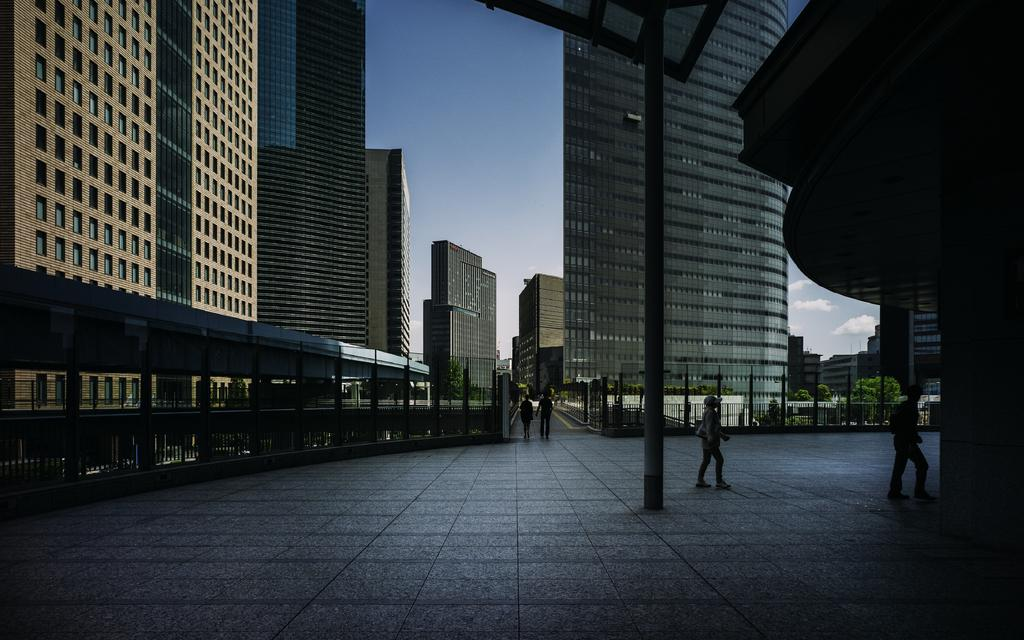What are the people in the image doing? The people in the image are walking. What structures can be seen in the image? There are buildings in the image. What type of vegetation is present in the image? There are trees in the image. What other objects can be seen in the image? There are poles and a metal fence in the image. What is visible in the sky at the top of the image? There are clouds in the sky at the top of the image. What type of tin sheet can be seen covering the buildings in the image? There is no tin sheet present in the image; the buildings are not covered by any material. 